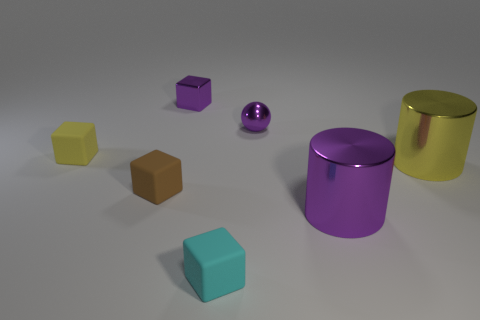There is a thing that is behind the large yellow thing and right of the tiny metal cube; what color is it?
Ensure brevity in your answer.  Purple. Is the tiny block that is in front of the big purple metal thing made of the same material as the big cylinder in front of the brown block?
Your response must be concise. No. Is the number of cylinders behind the large purple thing greater than the number of cyan objects that are to the left of the small metal cube?
Ensure brevity in your answer.  Yes. What is the shape of the yellow matte object that is the same size as the brown cube?
Give a very brief answer. Cube. What number of things are either purple shiny spheres or small purple objects that are on the right side of the tiny purple block?
Offer a very short reply. 1. Is the color of the tiny metallic block the same as the metal ball?
Your answer should be compact. Yes. There is a cyan rubber cube; how many tiny matte cubes are in front of it?
Make the answer very short. 0. There is a cube that is made of the same material as the large yellow cylinder; what color is it?
Offer a terse response. Purple. How many metal objects are tiny purple things or cyan cubes?
Make the answer very short. 2. Do the ball and the brown thing have the same material?
Provide a succinct answer. No. 